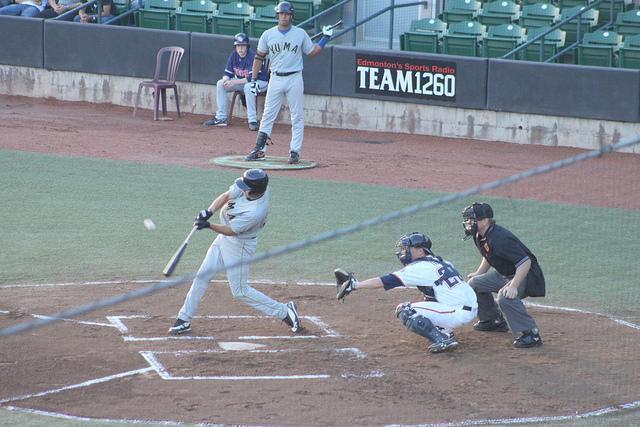How many people are there?
Give a very brief answer. 5. How many trains are there?
Give a very brief answer. 0. 